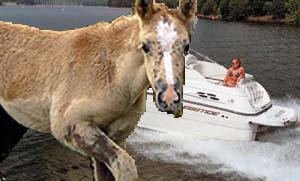How many unicorns are there in the image? There are no unicorns visible in the image. The creature depicted closely resembles a horse and it is positioned prominently in front of a background featuring a body of water and a speedboat. 